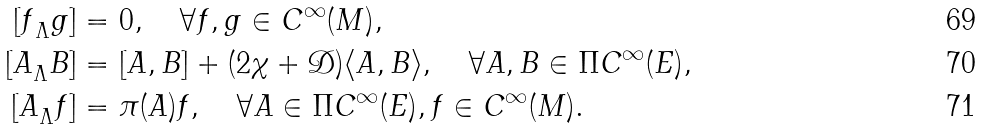<formula> <loc_0><loc_0><loc_500><loc_500>{ [ f } _ { \Lambda } g ] & = 0 , \quad \forall f , g \in C ^ { \infty } ( M ) , \\ { [ A } _ { \Lambda } B ] & = [ A , B ] + ( 2 \chi + \mathcal { D } ) \langle A , B \rangle , \quad \forall A , B \in \Pi C ^ { \infty } ( E ) , \\ { [ A } _ { \Lambda } f ] & = \pi ( A ) f , \quad \forall A \in \Pi C ^ { \infty } ( E ) , f \in C ^ { \infty } ( M ) .</formula> 